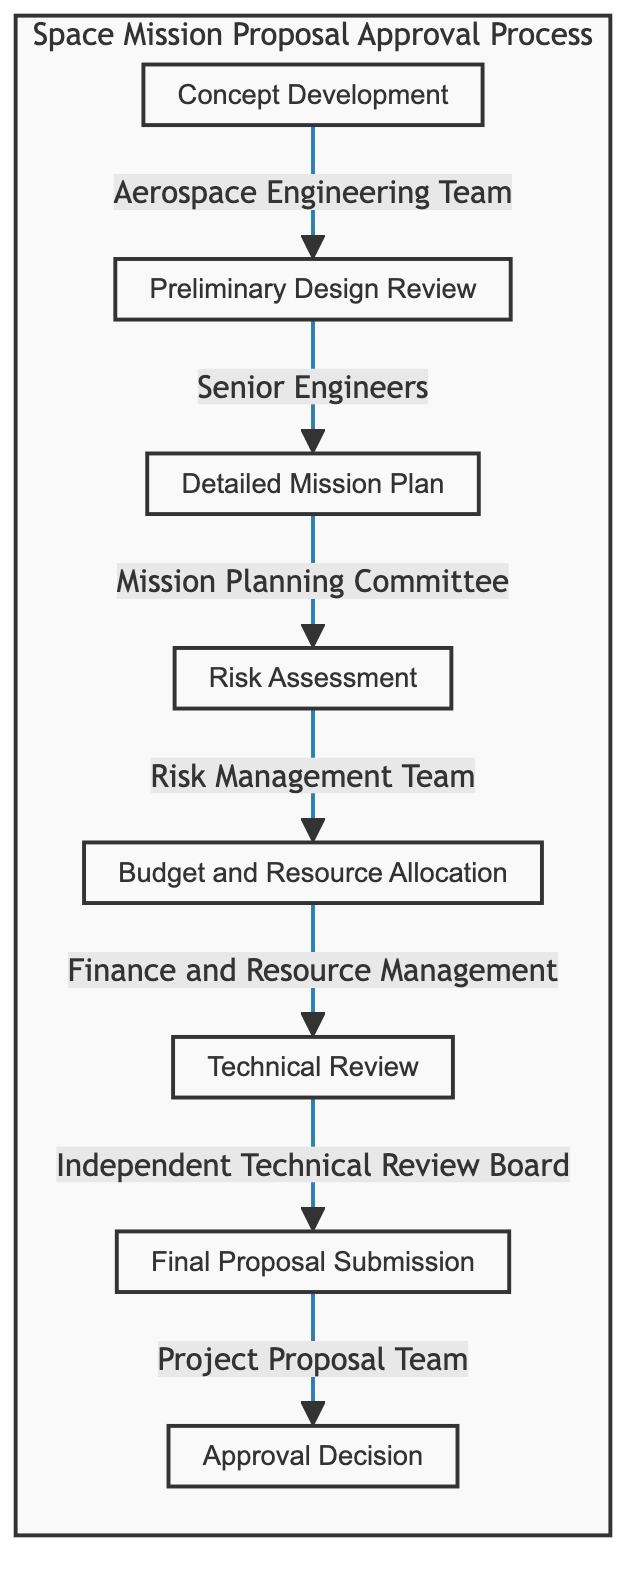What is the first step in the process? The first step listed in the flowchart is "Concept Development," where the aerospace engineering team begins to conceptualize the initial proposal.
Answer: Concept Development Who is responsible for the Risk Assessment? According to the flowchart, the "Risk Management Team" is responsible for conducting the risk assessment during the proposal process.
Answer: Risk Management Team How many nodes are in the diagram? The diagram contains a total of eight nodes, each representing a different step in the space mission proposal approval process.
Answer: Eight Which team conducts the Technical Review? The flowchart specifies that the "Independent Technical Review Board" is responsible for carrying out the technical review of the proposal.
Answer: Independent Technical Review Board What step comes after Detailed Mission Plan? Following "Detailed Mission Plan," the next step in the flowchart is "Risk Assessment," illustrating the sequential nature of the process.
Answer: Risk Assessment List the last step in the process. The final step as shown in the flowchart is "Approval Decision," representing the concluding outcome of the proposal process by the committee.
Answer: Approval Decision Which step is under the ownership of the Project Proposal Team? The "Final Proposal Submission" is the step that the flowchart indicates is managed by the Project Proposal Team.
Answer: Final Proposal Submission What is the relationship between Preliminary Design Review and Detailed Mission Plan? The flowchart shows a direct sequential relationship where the "Preliminary Design Review" leads into the "Detailed Mission Plan," indicating one step follows the other.
Answer: Leads to What is the main function of Budget and Resource Allocation? The purpose of "Budget and Resource Allocation" is to outline a detailed budget and allocate necessary resources for the mission, as described in the diagram.
Answer: Detailed budgeting and allocation of resources 